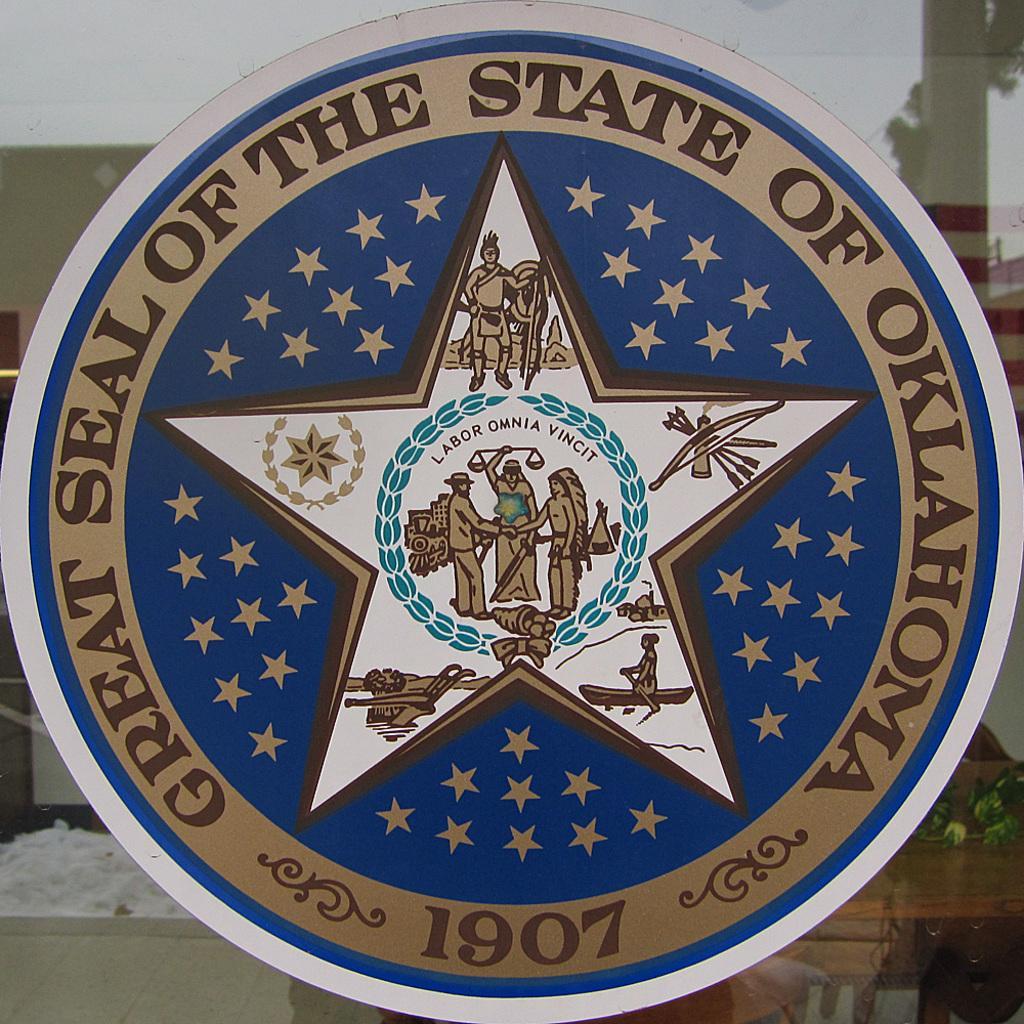In one or two sentences, can you explain what this image depicts? In the image we can see a board, circular in shape, on it there is a text and some pictures of people. This is a glass and a floor. 